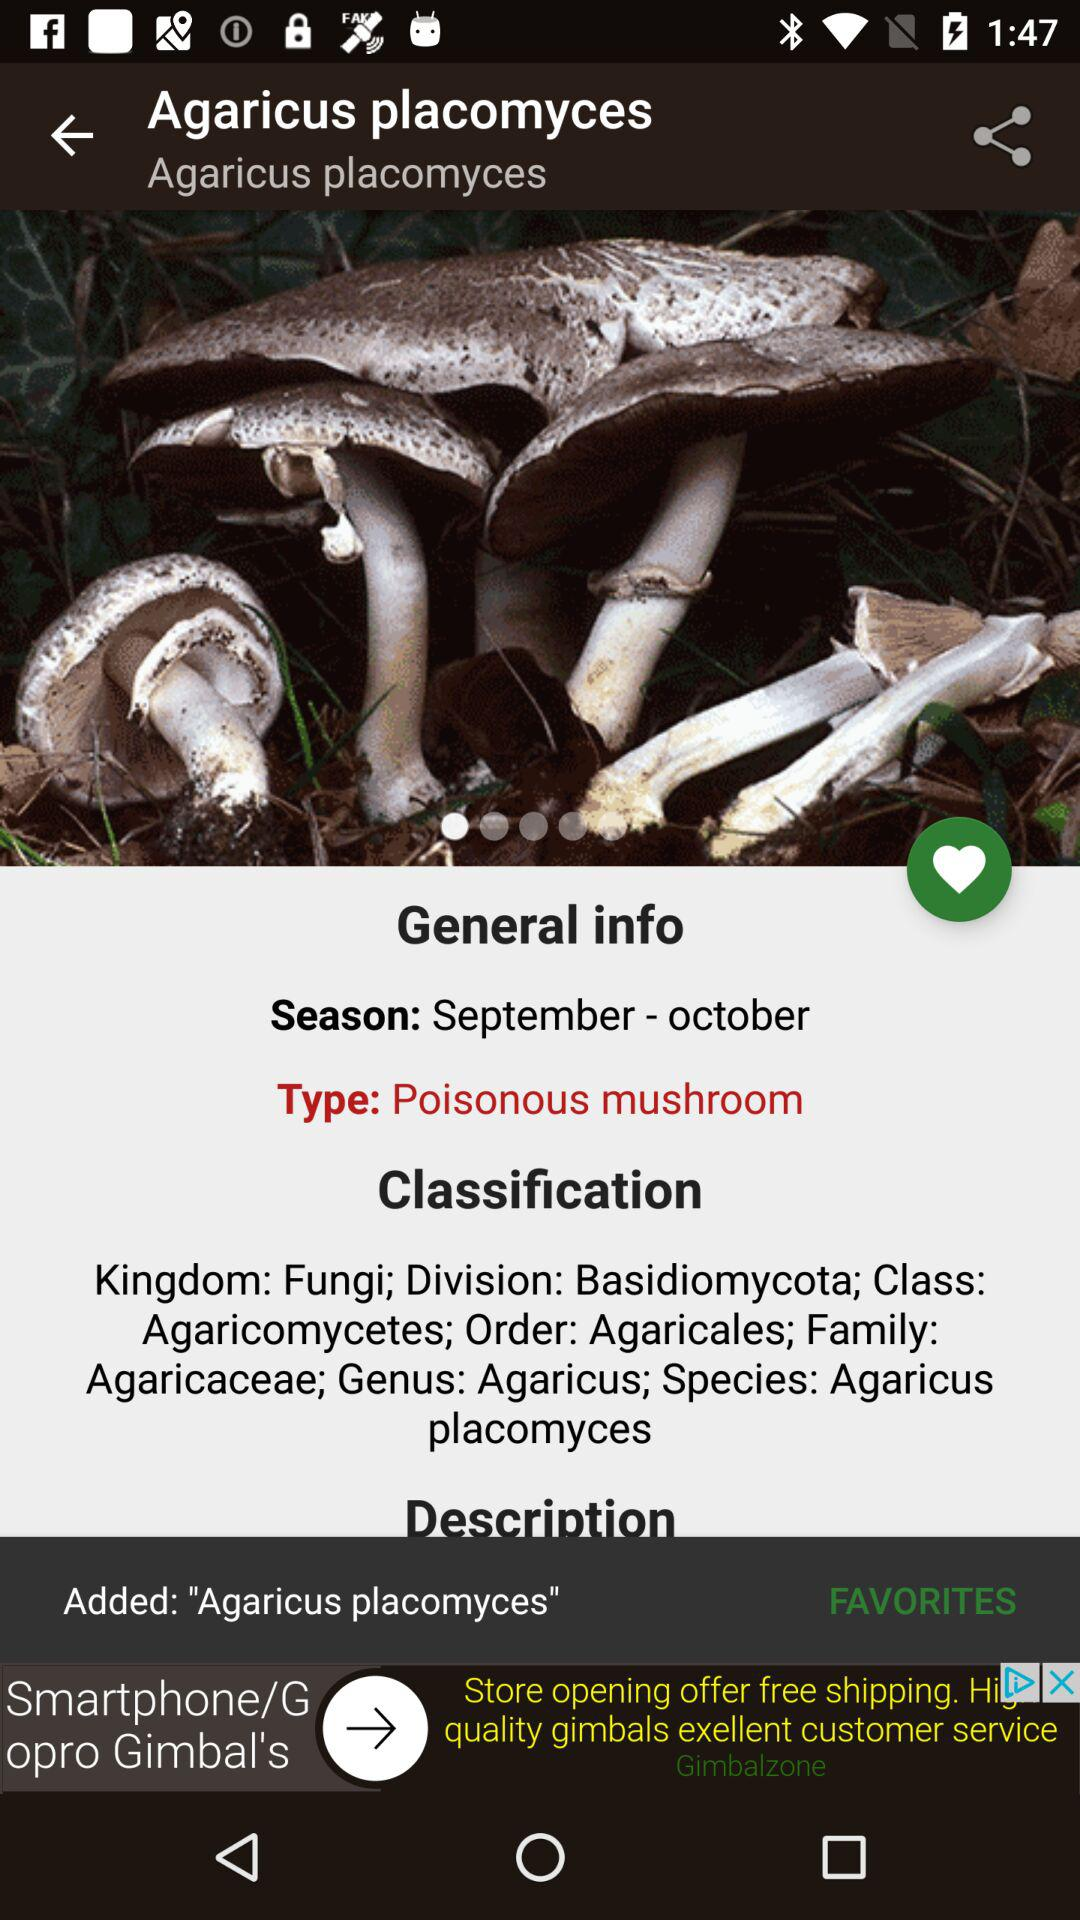What is the type? The type is "Poisonous mushroom". 